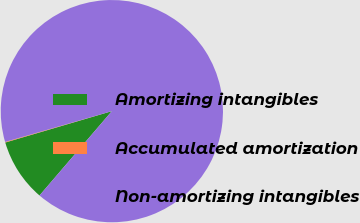Convert chart. <chart><loc_0><loc_0><loc_500><loc_500><pie_chart><fcel>Amortizing intangibles<fcel>Accumulated amortization<fcel>Non-amortizing intangibles<nl><fcel>9.16%<fcel>0.09%<fcel>90.75%<nl></chart> 